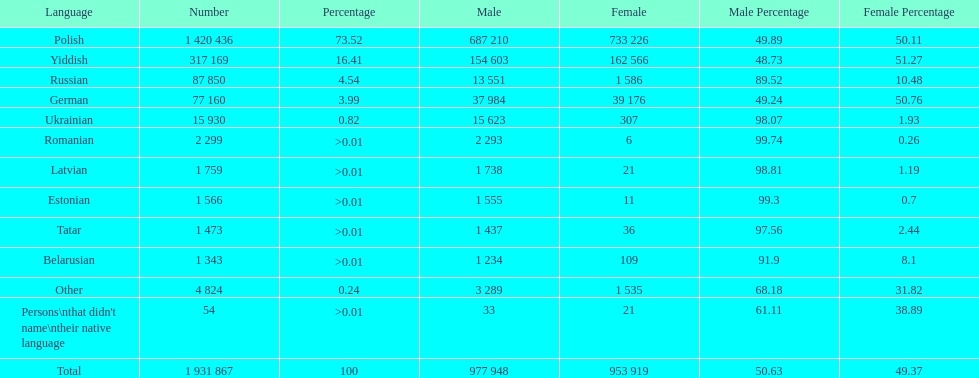Which language had the least female speakers? Romanian. 